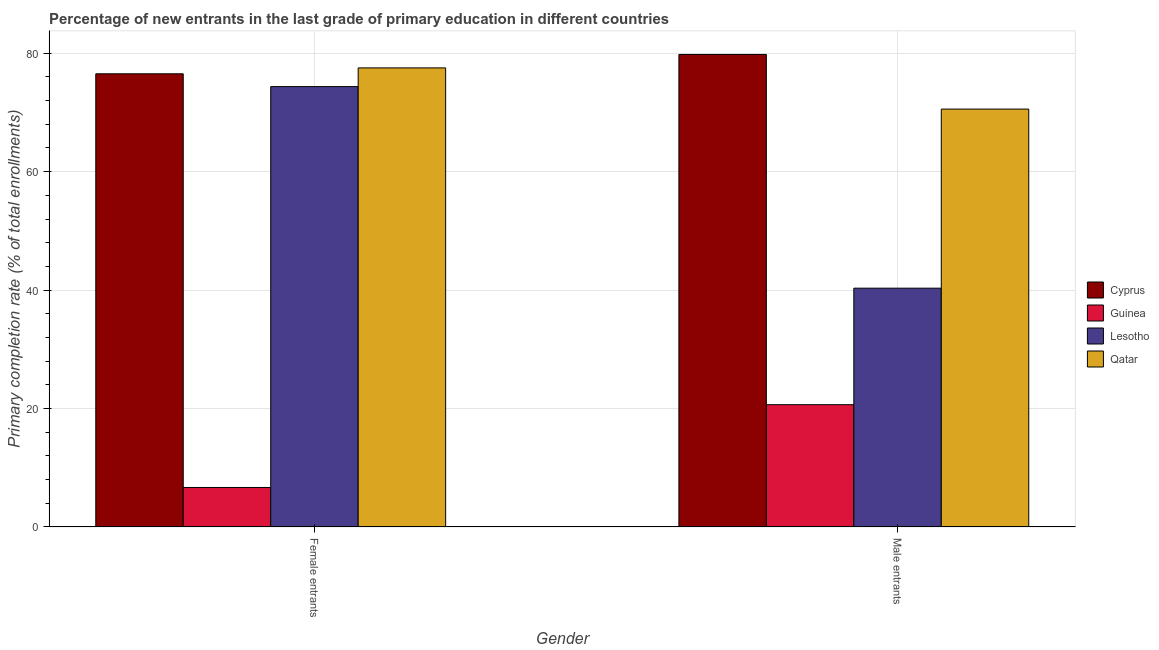Are the number of bars per tick equal to the number of legend labels?
Provide a short and direct response. Yes. What is the label of the 1st group of bars from the left?
Your answer should be compact. Female entrants. What is the primary completion rate of female entrants in Guinea?
Keep it short and to the point. 6.67. Across all countries, what is the maximum primary completion rate of male entrants?
Keep it short and to the point. 79.8. Across all countries, what is the minimum primary completion rate of male entrants?
Your response must be concise. 20.66. In which country was the primary completion rate of male entrants maximum?
Ensure brevity in your answer.  Cyprus. In which country was the primary completion rate of male entrants minimum?
Keep it short and to the point. Guinea. What is the total primary completion rate of female entrants in the graph?
Ensure brevity in your answer.  235.09. What is the difference between the primary completion rate of male entrants in Qatar and that in Cyprus?
Provide a short and direct response. -9.23. What is the difference between the primary completion rate of male entrants in Qatar and the primary completion rate of female entrants in Guinea?
Your answer should be compact. 63.9. What is the average primary completion rate of male entrants per country?
Provide a short and direct response. 52.84. What is the difference between the primary completion rate of female entrants and primary completion rate of male entrants in Guinea?
Offer a very short reply. -13.98. What is the ratio of the primary completion rate of male entrants in Lesotho to that in Guinea?
Make the answer very short. 1.95. What does the 4th bar from the left in Female entrants represents?
Give a very brief answer. Qatar. What does the 1st bar from the right in Male entrants represents?
Give a very brief answer. Qatar. How many bars are there?
Your answer should be very brief. 8. Are all the bars in the graph horizontal?
Provide a short and direct response. No. Does the graph contain any zero values?
Provide a short and direct response. No. Where does the legend appear in the graph?
Provide a short and direct response. Center right. How many legend labels are there?
Your answer should be compact. 4. How are the legend labels stacked?
Your response must be concise. Vertical. What is the title of the graph?
Keep it short and to the point. Percentage of new entrants in the last grade of primary education in different countries. Does "Ghana" appear as one of the legend labels in the graph?
Your answer should be very brief. No. What is the label or title of the Y-axis?
Make the answer very short. Primary completion rate (% of total enrollments). What is the Primary completion rate (% of total enrollments) in Cyprus in Female entrants?
Make the answer very short. 76.53. What is the Primary completion rate (% of total enrollments) of Guinea in Female entrants?
Offer a terse response. 6.67. What is the Primary completion rate (% of total enrollments) of Lesotho in Female entrants?
Ensure brevity in your answer.  74.37. What is the Primary completion rate (% of total enrollments) in Qatar in Female entrants?
Offer a terse response. 77.52. What is the Primary completion rate (% of total enrollments) in Cyprus in Male entrants?
Offer a very short reply. 79.8. What is the Primary completion rate (% of total enrollments) of Guinea in Male entrants?
Your response must be concise. 20.66. What is the Primary completion rate (% of total enrollments) of Lesotho in Male entrants?
Your answer should be very brief. 40.33. What is the Primary completion rate (% of total enrollments) of Qatar in Male entrants?
Offer a very short reply. 70.57. Across all Gender, what is the maximum Primary completion rate (% of total enrollments) of Cyprus?
Provide a succinct answer. 79.8. Across all Gender, what is the maximum Primary completion rate (% of total enrollments) in Guinea?
Provide a succinct answer. 20.66. Across all Gender, what is the maximum Primary completion rate (% of total enrollments) in Lesotho?
Make the answer very short. 74.37. Across all Gender, what is the maximum Primary completion rate (% of total enrollments) of Qatar?
Offer a terse response. 77.52. Across all Gender, what is the minimum Primary completion rate (% of total enrollments) in Cyprus?
Provide a short and direct response. 76.53. Across all Gender, what is the minimum Primary completion rate (% of total enrollments) in Guinea?
Offer a very short reply. 6.67. Across all Gender, what is the minimum Primary completion rate (% of total enrollments) in Lesotho?
Keep it short and to the point. 40.33. Across all Gender, what is the minimum Primary completion rate (% of total enrollments) in Qatar?
Keep it short and to the point. 70.57. What is the total Primary completion rate (% of total enrollments) of Cyprus in the graph?
Ensure brevity in your answer.  156.32. What is the total Primary completion rate (% of total enrollments) of Guinea in the graph?
Keep it short and to the point. 27.33. What is the total Primary completion rate (% of total enrollments) in Lesotho in the graph?
Your answer should be compact. 114.69. What is the total Primary completion rate (% of total enrollments) of Qatar in the graph?
Offer a terse response. 148.09. What is the difference between the Primary completion rate (% of total enrollments) of Cyprus in Female entrants and that in Male entrants?
Your response must be concise. -3.27. What is the difference between the Primary completion rate (% of total enrollments) in Guinea in Female entrants and that in Male entrants?
Offer a very short reply. -13.98. What is the difference between the Primary completion rate (% of total enrollments) in Lesotho in Female entrants and that in Male entrants?
Your answer should be compact. 34.04. What is the difference between the Primary completion rate (% of total enrollments) of Qatar in Female entrants and that in Male entrants?
Keep it short and to the point. 6.95. What is the difference between the Primary completion rate (% of total enrollments) in Cyprus in Female entrants and the Primary completion rate (% of total enrollments) in Guinea in Male entrants?
Ensure brevity in your answer.  55.87. What is the difference between the Primary completion rate (% of total enrollments) of Cyprus in Female entrants and the Primary completion rate (% of total enrollments) of Lesotho in Male entrants?
Keep it short and to the point. 36.2. What is the difference between the Primary completion rate (% of total enrollments) in Cyprus in Female entrants and the Primary completion rate (% of total enrollments) in Qatar in Male entrants?
Offer a very short reply. 5.96. What is the difference between the Primary completion rate (% of total enrollments) of Guinea in Female entrants and the Primary completion rate (% of total enrollments) of Lesotho in Male entrants?
Offer a very short reply. -33.65. What is the difference between the Primary completion rate (% of total enrollments) of Guinea in Female entrants and the Primary completion rate (% of total enrollments) of Qatar in Male entrants?
Keep it short and to the point. -63.9. What is the difference between the Primary completion rate (% of total enrollments) of Lesotho in Female entrants and the Primary completion rate (% of total enrollments) of Qatar in Male entrants?
Keep it short and to the point. 3.8. What is the average Primary completion rate (% of total enrollments) in Cyprus per Gender?
Ensure brevity in your answer.  78.16. What is the average Primary completion rate (% of total enrollments) of Guinea per Gender?
Make the answer very short. 13.66. What is the average Primary completion rate (% of total enrollments) in Lesotho per Gender?
Your answer should be compact. 57.35. What is the average Primary completion rate (% of total enrollments) of Qatar per Gender?
Offer a terse response. 74.05. What is the difference between the Primary completion rate (% of total enrollments) in Cyprus and Primary completion rate (% of total enrollments) in Guinea in Female entrants?
Make the answer very short. 69.86. What is the difference between the Primary completion rate (% of total enrollments) in Cyprus and Primary completion rate (% of total enrollments) in Lesotho in Female entrants?
Offer a very short reply. 2.16. What is the difference between the Primary completion rate (% of total enrollments) in Cyprus and Primary completion rate (% of total enrollments) in Qatar in Female entrants?
Give a very brief answer. -1. What is the difference between the Primary completion rate (% of total enrollments) in Guinea and Primary completion rate (% of total enrollments) in Lesotho in Female entrants?
Provide a short and direct response. -67.69. What is the difference between the Primary completion rate (% of total enrollments) in Guinea and Primary completion rate (% of total enrollments) in Qatar in Female entrants?
Make the answer very short. -70.85. What is the difference between the Primary completion rate (% of total enrollments) of Lesotho and Primary completion rate (% of total enrollments) of Qatar in Female entrants?
Your answer should be very brief. -3.16. What is the difference between the Primary completion rate (% of total enrollments) in Cyprus and Primary completion rate (% of total enrollments) in Guinea in Male entrants?
Ensure brevity in your answer.  59.14. What is the difference between the Primary completion rate (% of total enrollments) of Cyprus and Primary completion rate (% of total enrollments) of Lesotho in Male entrants?
Ensure brevity in your answer.  39.47. What is the difference between the Primary completion rate (% of total enrollments) of Cyprus and Primary completion rate (% of total enrollments) of Qatar in Male entrants?
Ensure brevity in your answer.  9.22. What is the difference between the Primary completion rate (% of total enrollments) in Guinea and Primary completion rate (% of total enrollments) in Lesotho in Male entrants?
Make the answer very short. -19.67. What is the difference between the Primary completion rate (% of total enrollments) in Guinea and Primary completion rate (% of total enrollments) in Qatar in Male entrants?
Your answer should be very brief. -49.92. What is the difference between the Primary completion rate (% of total enrollments) of Lesotho and Primary completion rate (% of total enrollments) of Qatar in Male entrants?
Your answer should be compact. -30.24. What is the ratio of the Primary completion rate (% of total enrollments) in Cyprus in Female entrants to that in Male entrants?
Ensure brevity in your answer.  0.96. What is the ratio of the Primary completion rate (% of total enrollments) of Guinea in Female entrants to that in Male entrants?
Offer a terse response. 0.32. What is the ratio of the Primary completion rate (% of total enrollments) of Lesotho in Female entrants to that in Male entrants?
Give a very brief answer. 1.84. What is the ratio of the Primary completion rate (% of total enrollments) in Qatar in Female entrants to that in Male entrants?
Keep it short and to the point. 1.1. What is the difference between the highest and the second highest Primary completion rate (% of total enrollments) of Cyprus?
Offer a terse response. 3.27. What is the difference between the highest and the second highest Primary completion rate (% of total enrollments) of Guinea?
Provide a short and direct response. 13.98. What is the difference between the highest and the second highest Primary completion rate (% of total enrollments) of Lesotho?
Provide a succinct answer. 34.04. What is the difference between the highest and the second highest Primary completion rate (% of total enrollments) of Qatar?
Offer a terse response. 6.95. What is the difference between the highest and the lowest Primary completion rate (% of total enrollments) in Cyprus?
Provide a short and direct response. 3.27. What is the difference between the highest and the lowest Primary completion rate (% of total enrollments) in Guinea?
Provide a short and direct response. 13.98. What is the difference between the highest and the lowest Primary completion rate (% of total enrollments) in Lesotho?
Give a very brief answer. 34.04. What is the difference between the highest and the lowest Primary completion rate (% of total enrollments) of Qatar?
Your answer should be very brief. 6.95. 